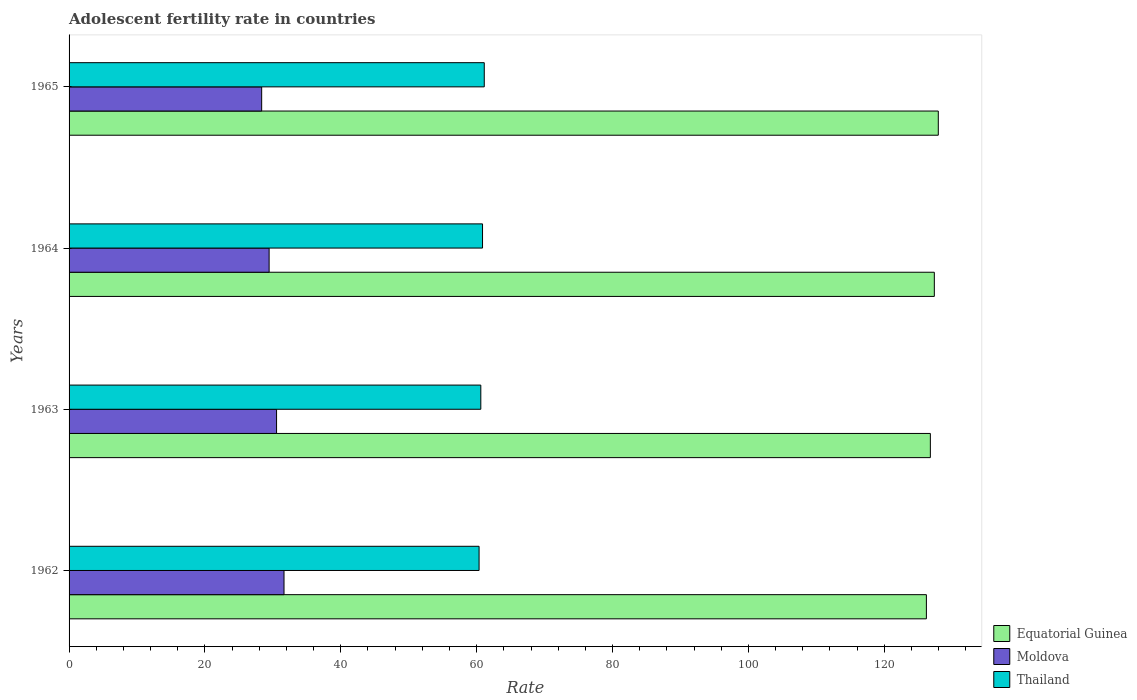How many different coloured bars are there?
Your response must be concise. 3. How many groups of bars are there?
Provide a short and direct response. 4. Are the number of bars on each tick of the Y-axis equal?
Your response must be concise. Yes. What is the label of the 2nd group of bars from the top?
Keep it short and to the point. 1964. In how many cases, is the number of bars for a given year not equal to the number of legend labels?
Offer a very short reply. 0. What is the adolescent fertility rate in Moldova in 1962?
Give a very brief answer. 31.64. Across all years, what is the maximum adolescent fertility rate in Equatorial Guinea?
Your response must be concise. 127.95. Across all years, what is the minimum adolescent fertility rate in Equatorial Guinea?
Offer a terse response. 126.19. In which year was the adolescent fertility rate in Moldova minimum?
Offer a very short reply. 1965. What is the total adolescent fertility rate in Equatorial Guinea in the graph?
Ensure brevity in your answer.  508.29. What is the difference between the adolescent fertility rate in Moldova in 1963 and that in 1964?
Make the answer very short. 1.1. What is the difference between the adolescent fertility rate in Thailand in 1962 and the adolescent fertility rate in Equatorial Guinea in 1963?
Provide a succinct answer. -66.43. What is the average adolescent fertility rate in Moldova per year?
Your answer should be compact. 29.99. In the year 1964, what is the difference between the adolescent fertility rate in Equatorial Guinea and adolescent fertility rate in Thailand?
Offer a terse response. 66.5. What is the ratio of the adolescent fertility rate in Moldova in 1962 to that in 1964?
Your response must be concise. 1.07. Is the adolescent fertility rate in Thailand in 1963 less than that in 1965?
Keep it short and to the point. Yes. Is the difference between the adolescent fertility rate in Equatorial Guinea in 1962 and 1963 greater than the difference between the adolescent fertility rate in Thailand in 1962 and 1963?
Give a very brief answer. No. What is the difference between the highest and the second highest adolescent fertility rate in Thailand?
Your response must be concise. 0.25. What is the difference between the highest and the lowest adolescent fertility rate in Thailand?
Give a very brief answer. 0.76. Is the sum of the adolescent fertility rate in Moldova in 1963 and 1965 greater than the maximum adolescent fertility rate in Equatorial Guinea across all years?
Your response must be concise. No. What does the 3rd bar from the top in 1962 represents?
Offer a terse response. Equatorial Guinea. What does the 3rd bar from the bottom in 1964 represents?
Your answer should be compact. Thailand. How many bars are there?
Your answer should be very brief. 12. Are the values on the major ticks of X-axis written in scientific E-notation?
Your response must be concise. No. Does the graph contain grids?
Offer a very short reply. No. Where does the legend appear in the graph?
Make the answer very short. Bottom right. How are the legend labels stacked?
Keep it short and to the point. Vertical. What is the title of the graph?
Ensure brevity in your answer.  Adolescent fertility rate in countries. Does "Solomon Islands" appear as one of the legend labels in the graph?
Offer a very short reply. No. What is the label or title of the X-axis?
Keep it short and to the point. Rate. What is the Rate of Equatorial Guinea in 1962?
Your response must be concise. 126.19. What is the Rate in Moldova in 1962?
Your response must be concise. 31.64. What is the Rate of Thailand in 1962?
Keep it short and to the point. 60.35. What is the Rate in Equatorial Guinea in 1963?
Your response must be concise. 126.78. What is the Rate of Moldova in 1963?
Give a very brief answer. 30.54. What is the Rate in Thailand in 1963?
Provide a succinct answer. 60.61. What is the Rate in Equatorial Guinea in 1964?
Make the answer very short. 127.36. What is the Rate of Moldova in 1964?
Offer a very short reply. 29.45. What is the Rate of Thailand in 1964?
Make the answer very short. 60.86. What is the Rate in Equatorial Guinea in 1965?
Make the answer very short. 127.95. What is the Rate in Moldova in 1965?
Provide a short and direct response. 28.35. What is the Rate in Thailand in 1965?
Ensure brevity in your answer.  61.11. Across all years, what is the maximum Rate in Equatorial Guinea?
Your response must be concise. 127.95. Across all years, what is the maximum Rate in Moldova?
Make the answer very short. 31.64. Across all years, what is the maximum Rate in Thailand?
Your answer should be very brief. 61.11. Across all years, what is the minimum Rate of Equatorial Guinea?
Offer a terse response. 126.19. Across all years, what is the minimum Rate in Moldova?
Provide a short and direct response. 28.35. Across all years, what is the minimum Rate in Thailand?
Offer a terse response. 60.35. What is the total Rate of Equatorial Guinea in the graph?
Offer a very short reply. 508.29. What is the total Rate in Moldova in the graph?
Your answer should be very brief. 119.98. What is the total Rate of Thailand in the graph?
Provide a succinct answer. 242.93. What is the difference between the Rate in Equatorial Guinea in 1962 and that in 1963?
Give a very brief answer. -0.58. What is the difference between the Rate of Moldova in 1962 and that in 1963?
Provide a succinct answer. 1.1. What is the difference between the Rate of Thailand in 1962 and that in 1963?
Offer a very short reply. -0.25. What is the difference between the Rate in Equatorial Guinea in 1962 and that in 1964?
Your response must be concise. -1.17. What is the difference between the Rate of Moldova in 1962 and that in 1964?
Offer a very short reply. 2.19. What is the difference between the Rate in Thailand in 1962 and that in 1964?
Your answer should be very brief. -0.51. What is the difference between the Rate in Equatorial Guinea in 1962 and that in 1965?
Provide a short and direct response. -1.75. What is the difference between the Rate in Moldova in 1962 and that in 1965?
Offer a terse response. 3.29. What is the difference between the Rate in Thailand in 1962 and that in 1965?
Ensure brevity in your answer.  -0.76. What is the difference between the Rate of Equatorial Guinea in 1963 and that in 1964?
Your answer should be very brief. -0.58. What is the difference between the Rate of Moldova in 1963 and that in 1964?
Provide a succinct answer. 1.1. What is the difference between the Rate of Thailand in 1963 and that in 1964?
Provide a succinct answer. -0.25. What is the difference between the Rate in Equatorial Guinea in 1963 and that in 1965?
Your response must be concise. -1.17. What is the difference between the Rate of Moldova in 1963 and that in 1965?
Your answer should be very brief. 2.19. What is the difference between the Rate in Thailand in 1963 and that in 1965?
Provide a succinct answer. -0.51. What is the difference between the Rate of Equatorial Guinea in 1964 and that in 1965?
Ensure brevity in your answer.  -0.58. What is the difference between the Rate of Moldova in 1964 and that in 1965?
Your response must be concise. 1.1. What is the difference between the Rate in Thailand in 1964 and that in 1965?
Provide a short and direct response. -0.25. What is the difference between the Rate in Equatorial Guinea in 1962 and the Rate in Moldova in 1963?
Give a very brief answer. 95.65. What is the difference between the Rate of Equatorial Guinea in 1962 and the Rate of Thailand in 1963?
Give a very brief answer. 65.59. What is the difference between the Rate in Moldova in 1962 and the Rate in Thailand in 1963?
Provide a succinct answer. -28.97. What is the difference between the Rate in Equatorial Guinea in 1962 and the Rate in Moldova in 1964?
Offer a very short reply. 96.75. What is the difference between the Rate in Equatorial Guinea in 1962 and the Rate in Thailand in 1964?
Make the answer very short. 65.33. What is the difference between the Rate in Moldova in 1962 and the Rate in Thailand in 1964?
Ensure brevity in your answer.  -29.22. What is the difference between the Rate in Equatorial Guinea in 1962 and the Rate in Moldova in 1965?
Make the answer very short. 97.84. What is the difference between the Rate in Equatorial Guinea in 1962 and the Rate in Thailand in 1965?
Ensure brevity in your answer.  65.08. What is the difference between the Rate in Moldova in 1962 and the Rate in Thailand in 1965?
Make the answer very short. -29.48. What is the difference between the Rate of Equatorial Guinea in 1963 and the Rate of Moldova in 1964?
Your response must be concise. 97.33. What is the difference between the Rate of Equatorial Guinea in 1963 and the Rate of Thailand in 1964?
Ensure brevity in your answer.  65.92. What is the difference between the Rate in Moldova in 1963 and the Rate in Thailand in 1964?
Offer a terse response. -30.32. What is the difference between the Rate in Equatorial Guinea in 1963 and the Rate in Moldova in 1965?
Make the answer very short. 98.43. What is the difference between the Rate of Equatorial Guinea in 1963 and the Rate of Thailand in 1965?
Give a very brief answer. 65.66. What is the difference between the Rate in Moldova in 1963 and the Rate in Thailand in 1965?
Offer a terse response. -30.57. What is the difference between the Rate in Equatorial Guinea in 1964 and the Rate in Moldova in 1965?
Make the answer very short. 99.01. What is the difference between the Rate of Equatorial Guinea in 1964 and the Rate of Thailand in 1965?
Ensure brevity in your answer.  66.25. What is the difference between the Rate in Moldova in 1964 and the Rate in Thailand in 1965?
Keep it short and to the point. -31.67. What is the average Rate of Equatorial Guinea per year?
Offer a very short reply. 127.07. What is the average Rate of Moldova per year?
Keep it short and to the point. 29.99. What is the average Rate of Thailand per year?
Make the answer very short. 60.73. In the year 1962, what is the difference between the Rate in Equatorial Guinea and Rate in Moldova?
Provide a succinct answer. 94.56. In the year 1962, what is the difference between the Rate in Equatorial Guinea and Rate in Thailand?
Provide a succinct answer. 65.84. In the year 1962, what is the difference between the Rate in Moldova and Rate in Thailand?
Your response must be concise. -28.71. In the year 1963, what is the difference between the Rate in Equatorial Guinea and Rate in Moldova?
Give a very brief answer. 96.24. In the year 1963, what is the difference between the Rate in Equatorial Guinea and Rate in Thailand?
Provide a succinct answer. 66.17. In the year 1963, what is the difference between the Rate in Moldova and Rate in Thailand?
Your response must be concise. -30.06. In the year 1964, what is the difference between the Rate of Equatorial Guinea and Rate of Moldova?
Make the answer very short. 97.92. In the year 1964, what is the difference between the Rate of Equatorial Guinea and Rate of Thailand?
Give a very brief answer. 66.5. In the year 1964, what is the difference between the Rate in Moldova and Rate in Thailand?
Your response must be concise. -31.41. In the year 1965, what is the difference between the Rate of Equatorial Guinea and Rate of Moldova?
Make the answer very short. 99.6. In the year 1965, what is the difference between the Rate in Equatorial Guinea and Rate in Thailand?
Offer a very short reply. 66.83. In the year 1965, what is the difference between the Rate in Moldova and Rate in Thailand?
Offer a very short reply. -32.76. What is the ratio of the Rate of Moldova in 1962 to that in 1963?
Offer a very short reply. 1.04. What is the ratio of the Rate in Equatorial Guinea in 1962 to that in 1964?
Provide a succinct answer. 0.99. What is the ratio of the Rate in Moldova in 1962 to that in 1964?
Your answer should be compact. 1.07. What is the ratio of the Rate in Equatorial Guinea in 1962 to that in 1965?
Provide a succinct answer. 0.99. What is the ratio of the Rate in Moldova in 1962 to that in 1965?
Ensure brevity in your answer.  1.12. What is the ratio of the Rate of Thailand in 1962 to that in 1965?
Provide a succinct answer. 0.99. What is the ratio of the Rate of Moldova in 1963 to that in 1964?
Provide a short and direct response. 1.04. What is the ratio of the Rate of Equatorial Guinea in 1963 to that in 1965?
Offer a very short reply. 0.99. What is the ratio of the Rate of Moldova in 1963 to that in 1965?
Your answer should be very brief. 1.08. What is the ratio of the Rate in Thailand in 1963 to that in 1965?
Offer a very short reply. 0.99. What is the ratio of the Rate in Equatorial Guinea in 1964 to that in 1965?
Make the answer very short. 1. What is the ratio of the Rate of Moldova in 1964 to that in 1965?
Your response must be concise. 1.04. What is the ratio of the Rate in Thailand in 1964 to that in 1965?
Offer a very short reply. 1. What is the difference between the highest and the second highest Rate of Equatorial Guinea?
Provide a short and direct response. 0.58. What is the difference between the highest and the second highest Rate in Moldova?
Provide a succinct answer. 1.1. What is the difference between the highest and the second highest Rate in Thailand?
Provide a short and direct response. 0.25. What is the difference between the highest and the lowest Rate of Equatorial Guinea?
Provide a short and direct response. 1.75. What is the difference between the highest and the lowest Rate of Moldova?
Make the answer very short. 3.29. What is the difference between the highest and the lowest Rate of Thailand?
Offer a very short reply. 0.76. 